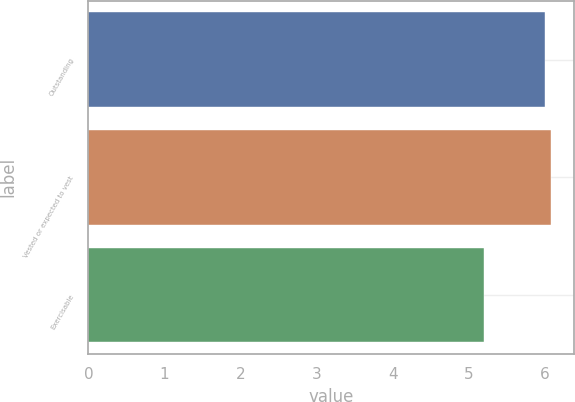Convert chart to OTSL. <chart><loc_0><loc_0><loc_500><loc_500><bar_chart><fcel>Outstanding<fcel>Vested or expected to vest<fcel>Exercisable<nl><fcel>6<fcel>6.08<fcel>5.2<nl></chart> 